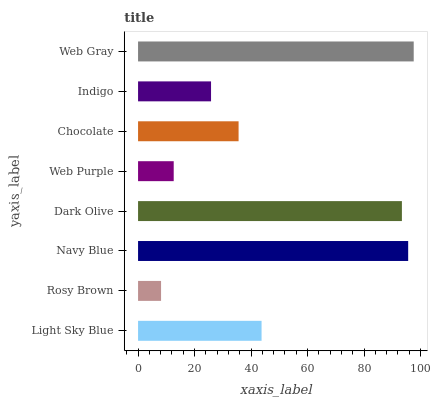Is Rosy Brown the minimum?
Answer yes or no. Yes. Is Web Gray the maximum?
Answer yes or no. Yes. Is Navy Blue the minimum?
Answer yes or no. No. Is Navy Blue the maximum?
Answer yes or no. No. Is Navy Blue greater than Rosy Brown?
Answer yes or no. Yes. Is Rosy Brown less than Navy Blue?
Answer yes or no. Yes. Is Rosy Brown greater than Navy Blue?
Answer yes or no. No. Is Navy Blue less than Rosy Brown?
Answer yes or no. No. Is Light Sky Blue the high median?
Answer yes or no. Yes. Is Chocolate the low median?
Answer yes or no. Yes. Is Indigo the high median?
Answer yes or no. No. Is Dark Olive the low median?
Answer yes or no. No. 